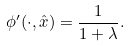Convert formula to latex. <formula><loc_0><loc_0><loc_500><loc_500>\phi ^ { \prime } ( \cdot , \hat { x } ) = \frac { 1 } { 1 + \lambda } .</formula> 